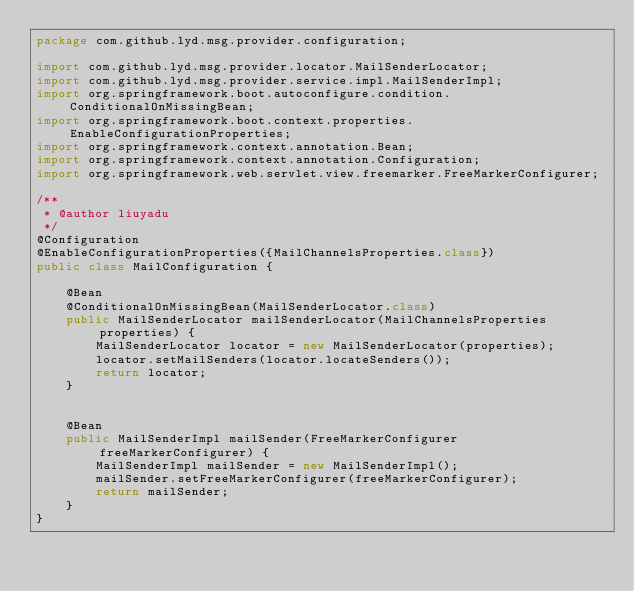<code> <loc_0><loc_0><loc_500><loc_500><_Java_>package com.github.lyd.msg.provider.configuration;

import com.github.lyd.msg.provider.locator.MailSenderLocator;
import com.github.lyd.msg.provider.service.impl.MailSenderImpl;
import org.springframework.boot.autoconfigure.condition.ConditionalOnMissingBean;
import org.springframework.boot.context.properties.EnableConfigurationProperties;
import org.springframework.context.annotation.Bean;
import org.springframework.context.annotation.Configuration;
import org.springframework.web.servlet.view.freemarker.FreeMarkerConfigurer;

/**
 * @author liuyadu
 */
@Configuration
@EnableConfigurationProperties({MailChannelsProperties.class})
public class MailConfiguration {

    @Bean
    @ConditionalOnMissingBean(MailSenderLocator.class)
    public MailSenderLocator mailSenderLocator(MailChannelsProperties properties) {
        MailSenderLocator locator = new MailSenderLocator(properties);
        locator.setMailSenders(locator.locateSenders());
        return locator;
    }


    @Bean
    public MailSenderImpl mailSender(FreeMarkerConfigurer freeMarkerConfigurer) {
        MailSenderImpl mailSender = new MailSenderImpl();
        mailSender.setFreeMarkerConfigurer(freeMarkerConfigurer);
        return mailSender;
    }
}
</code> 